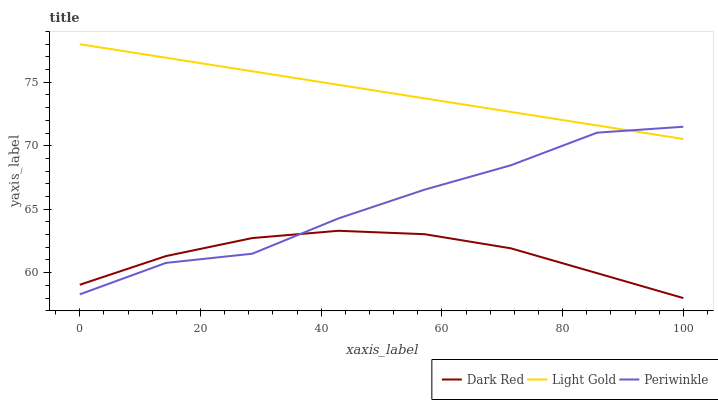Does Periwinkle have the minimum area under the curve?
Answer yes or no. No. Does Periwinkle have the maximum area under the curve?
Answer yes or no. No. Is Periwinkle the smoothest?
Answer yes or no. No. Is Light Gold the roughest?
Answer yes or no. No. Does Periwinkle have the lowest value?
Answer yes or no. No. Does Periwinkle have the highest value?
Answer yes or no. No. Is Dark Red less than Light Gold?
Answer yes or no. Yes. Is Light Gold greater than Dark Red?
Answer yes or no. Yes. Does Dark Red intersect Light Gold?
Answer yes or no. No. 